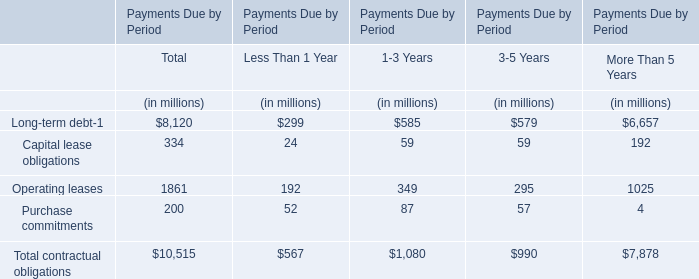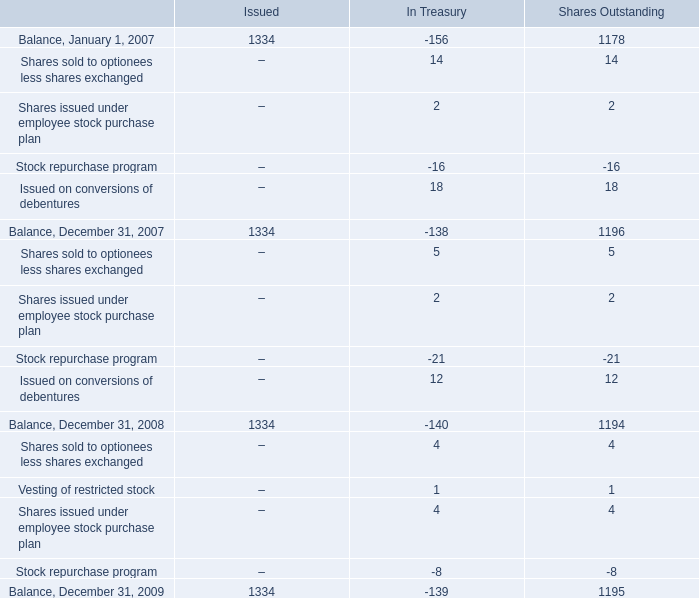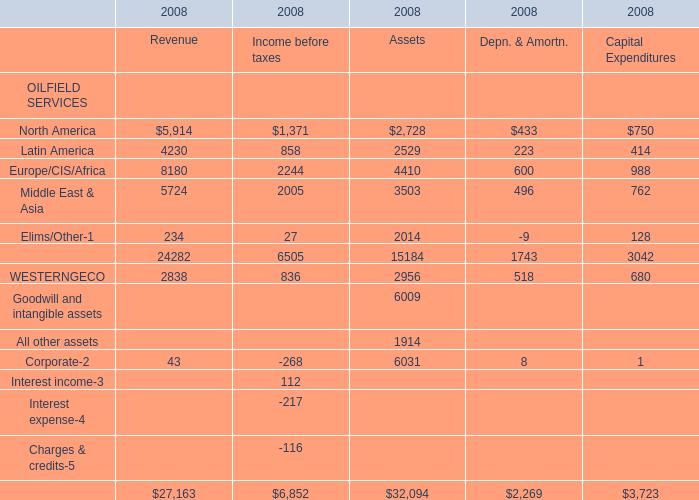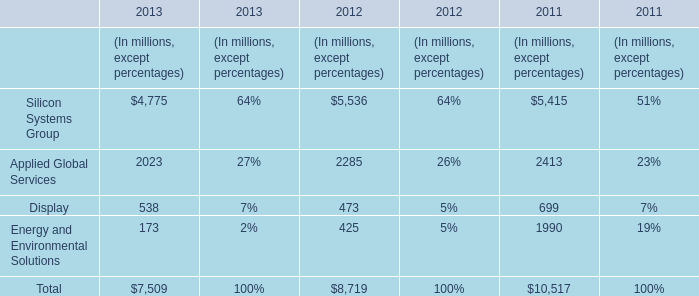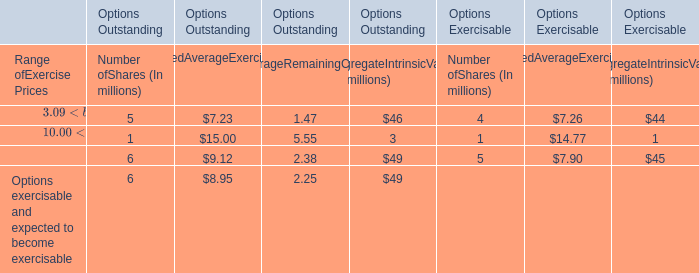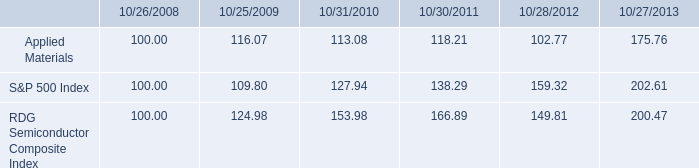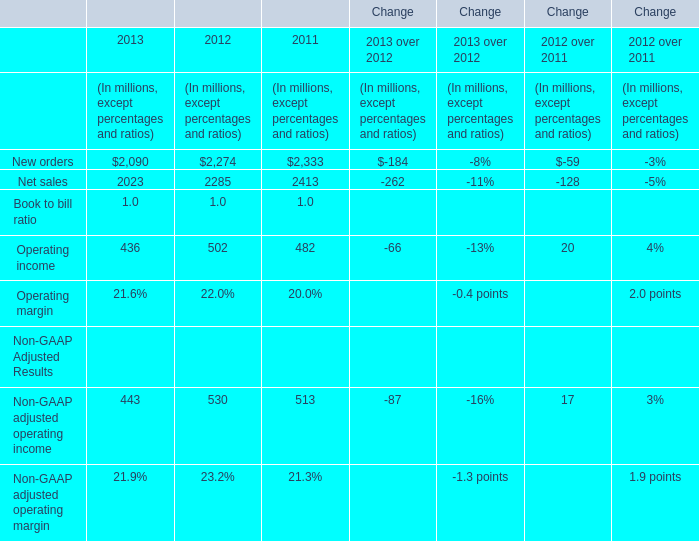What is the sum of Europe/CIS/Africa in the range of 1 and 2300 in 2008? (in million) 
Computations: ((2244 + 600) + 988)
Answer: 3832.0. 